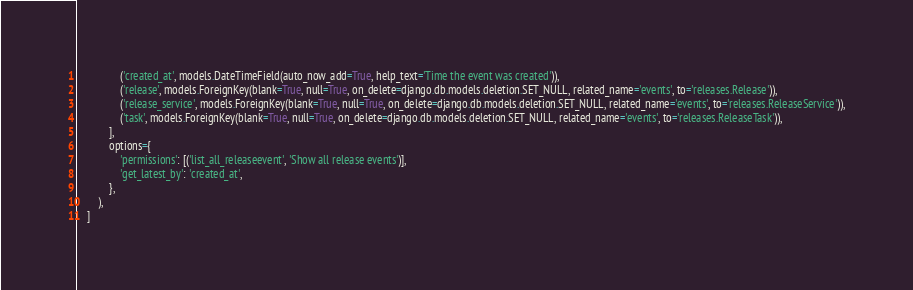<code> <loc_0><loc_0><loc_500><loc_500><_Python_>                ('created_at', models.DateTimeField(auto_now_add=True, help_text='Time the event was created')),
                ('release', models.ForeignKey(blank=True, null=True, on_delete=django.db.models.deletion.SET_NULL, related_name='events', to='releases.Release')),
                ('release_service', models.ForeignKey(blank=True, null=True, on_delete=django.db.models.deletion.SET_NULL, related_name='events', to='releases.ReleaseService')),
                ('task', models.ForeignKey(blank=True, null=True, on_delete=django.db.models.deletion.SET_NULL, related_name='events', to='releases.ReleaseTask')),
            ],
            options={
                'permissions': [('list_all_releaseevent', 'Show all release events')],
                'get_latest_by': 'created_at',
            },
        ),
    ]
</code> 